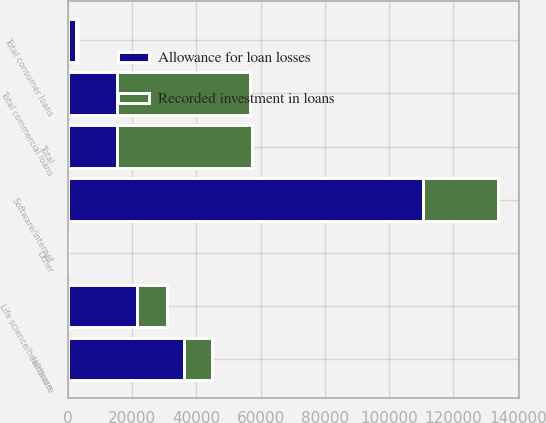<chart> <loc_0><loc_0><loc_500><loc_500><stacked_bar_chart><ecel><fcel>Software/internet<fcel>Hardware<fcel>Life science/healthcare<fcel>Other<fcel>Total commercial loans<fcel>Total consumer loans<fcel>Total<nl><fcel>Recorded investment in loans<fcel>23088<fcel>8450<fcel>9315<fcel>32<fcel>41215<fcel>578<fcel>41793<nl><fcel>Allowance for loan losses<fcel>110654<fcel>36350<fcel>21687<fcel>32<fcel>15501<fcel>2603<fcel>15501<nl></chart> 